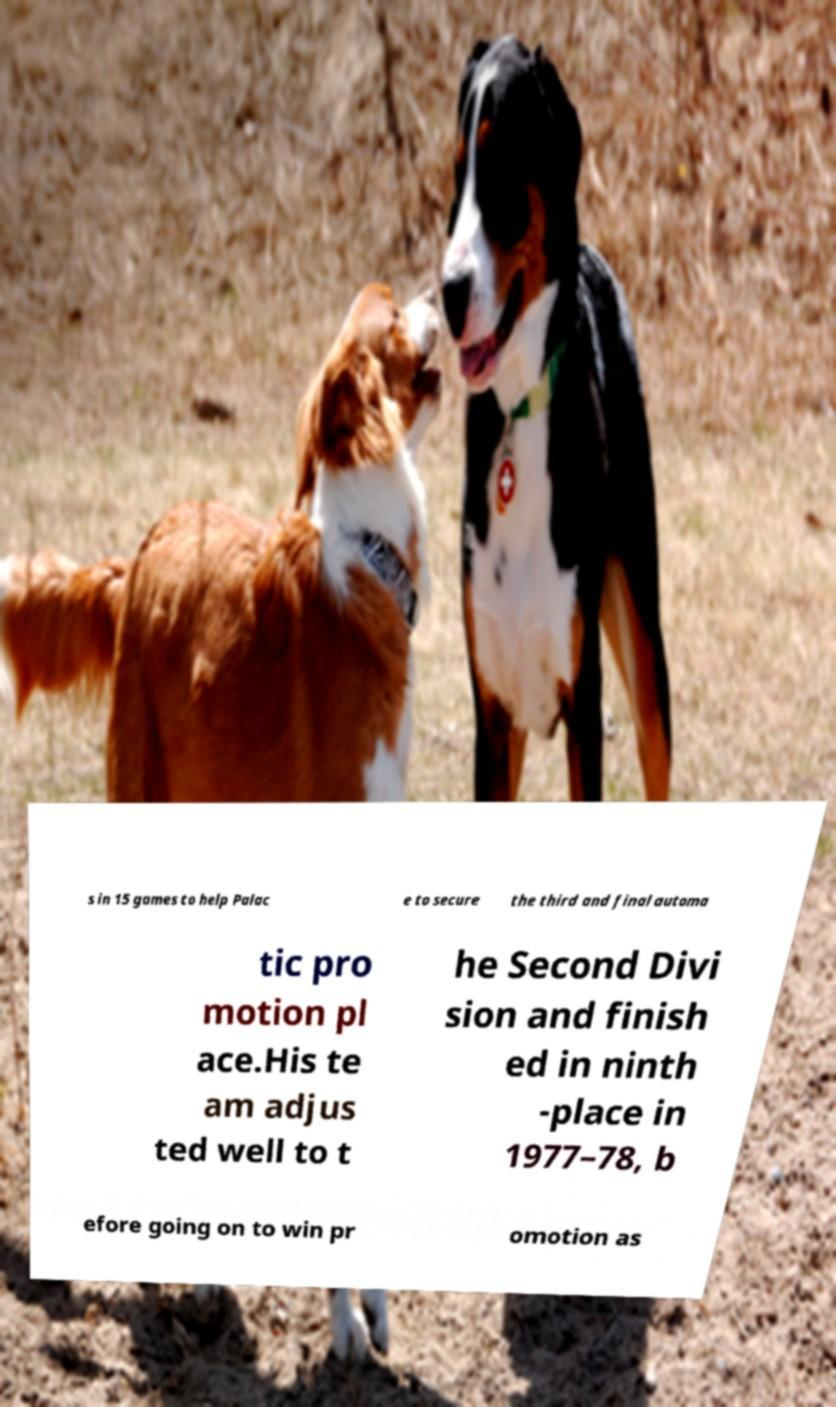Can you accurately transcribe the text from the provided image for me? s in 15 games to help Palac e to secure the third and final automa tic pro motion pl ace.His te am adjus ted well to t he Second Divi sion and finish ed in ninth -place in 1977–78, b efore going on to win pr omotion as 